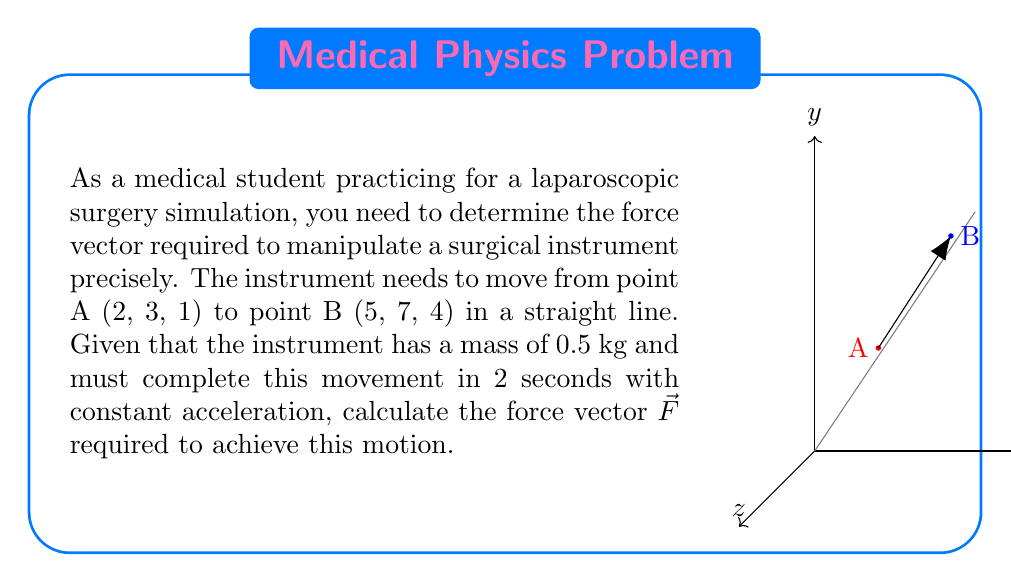Can you answer this question? Let's approach this step-by-step:

1) First, we need to find the displacement vector $\vec{d}$:
   $$\vec{d} = (5-2, 7-3, 4-1) = (3, 4, 3)$$

2) The acceleration vector $\vec{a}$ will be in the same direction as the displacement. We can find it using the equation:
   $$\vec{d} = \frac{1}{2}\vec{a}t^2$$
   where $t = 2$ seconds.

3) Rearranging this equation:
   $$\vec{a} = \frac{2\vec{d}}{t^2} = \frac{2(3, 4, 3)}{2^2} = (1.5, 2, 1.5)$$

4) Now we can use Newton's Second Law, $\vec{F} = m\vec{a}$, where $m = 0.5$ kg:
   $$\vec{F} = 0.5(1.5, 2, 1.5) = (0.75, 1, 0.75)$$

5) Therefore, the force vector required is $(0.75, 1, 0.75)$ N.
Answer: $\vec{F} = (0.75, 1, 0.75)$ N 